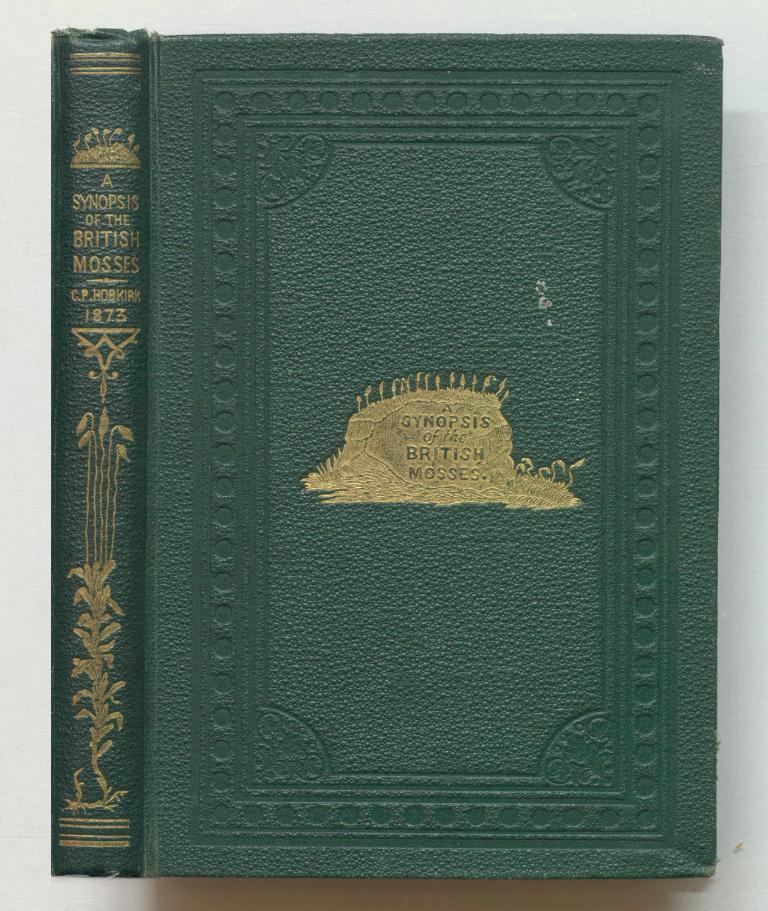In what year was this book written?
Keep it short and to the point. 1873. 